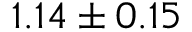<formula> <loc_0><loc_0><loc_500><loc_500>1 . 1 4 \pm 0 . 1 5</formula> 